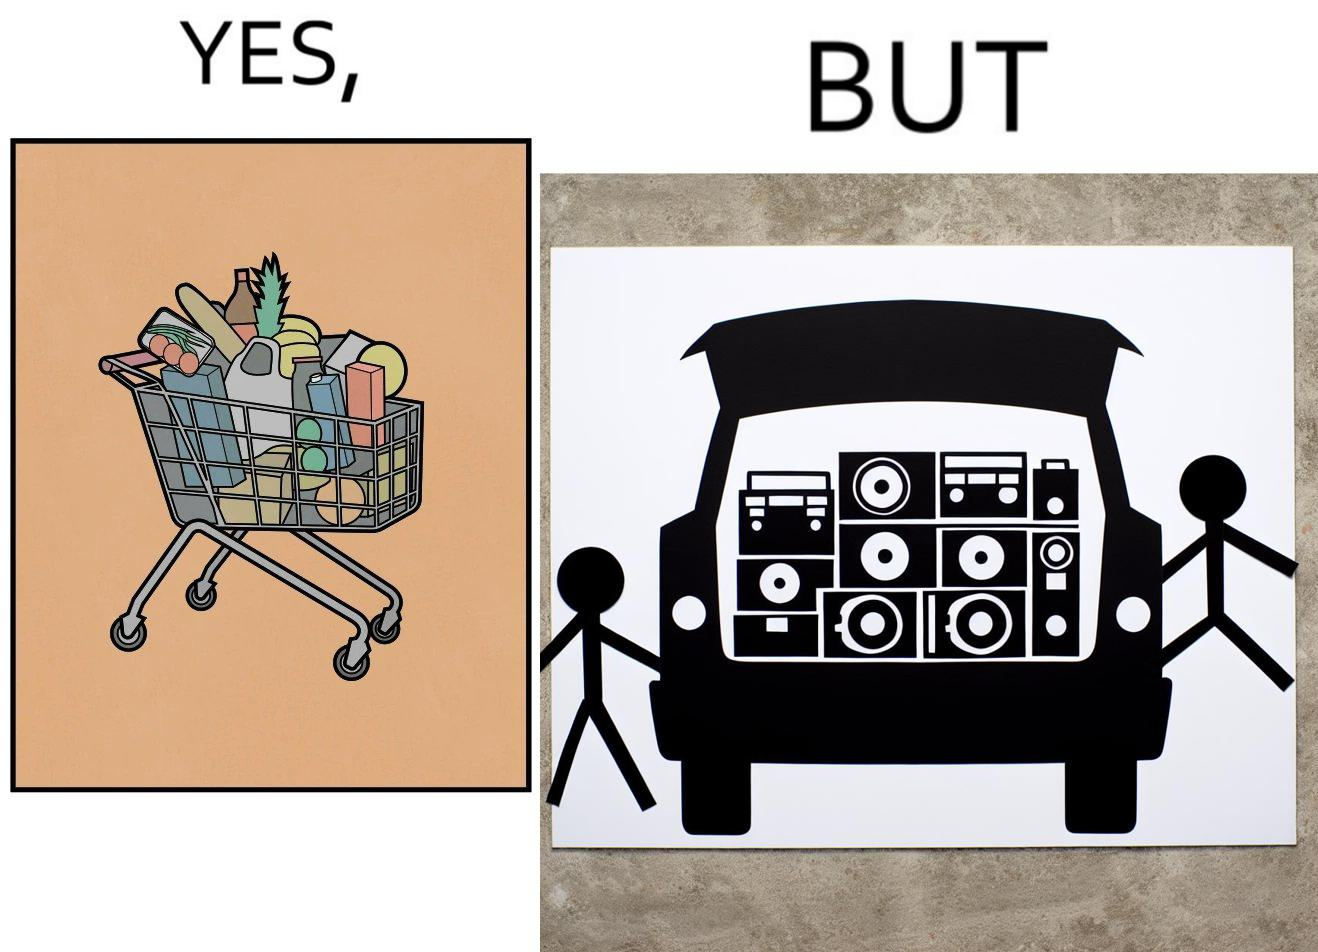What makes this image funny or satirical? The image is ironic, because a car trunk was earlier designed to keep some extra luggage or things but people nowadays get speakers installed in the trunk which in turn reduces the space in the trunk and making it difficult for people to store the extra luggage in the trunk 